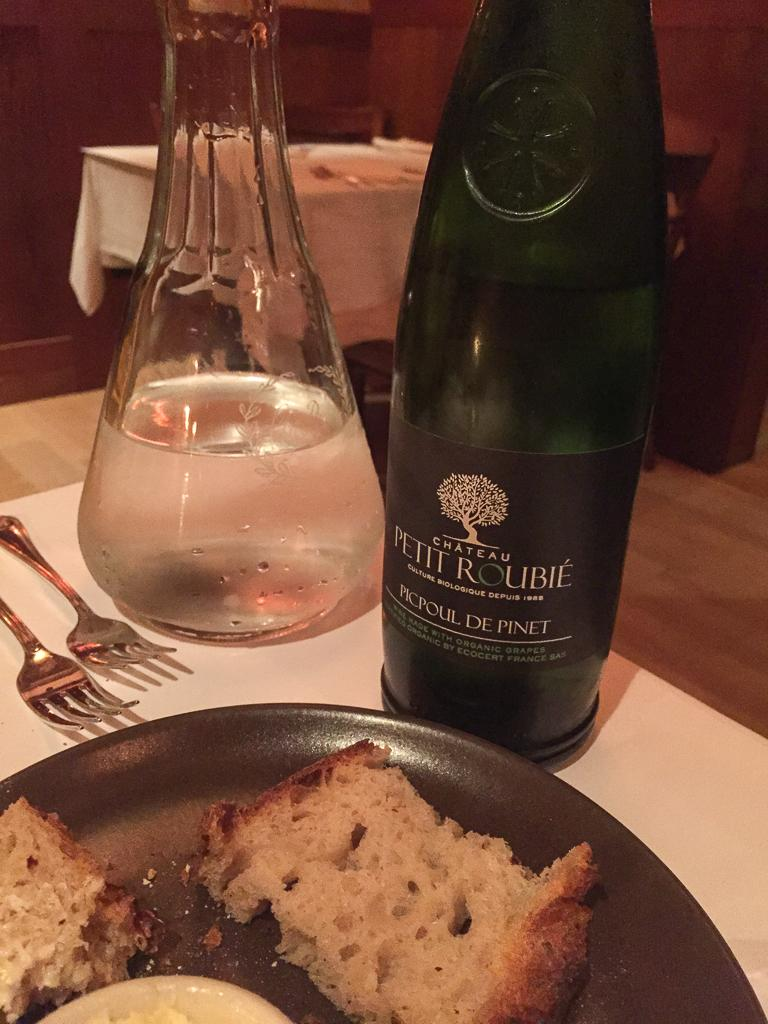What is on the plate that is visible in the image? There is food on the plate in the image. Besides the plate, what other items can be seen in the image? There is a bottle and forks visible in the image. Where are these items located in the image? They are on a table in the image. What type of pencil can be seen on the plate in the image? There is no pencil present on the plate or in the image. 